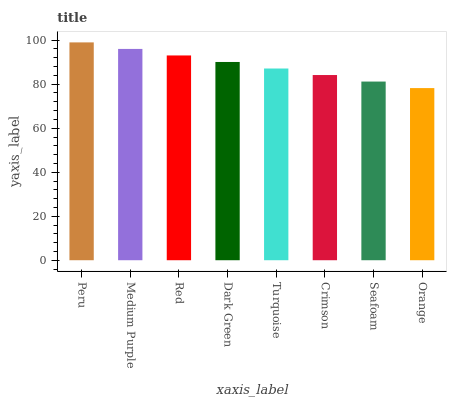Is Orange the minimum?
Answer yes or no. Yes. Is Peru the maximum?
Answer yes or no. Yes. Is Medium Purple the minimum?
Answer yes or no. No. Is Medium Purple the maximum?
Answer yes or no. No. Is Peru greater than Medium Purple?
Answer yes or no. Yes. Is Medium Purple less than Peru?
Answer yes or no. Yes. Is Medium Purple greater than Peru?
Answer yes or no. No. Is Peru less than Medium Purple?
Answer yes or no. No. Is Dark Green the high median?
Answer yes or no. Yes. Is Turquoise the low median?
Answer yes or no. Yes. Is Orange the high median?
Answer yes or no. No. Is Crimson the low median?
Answer yes or no. No. 